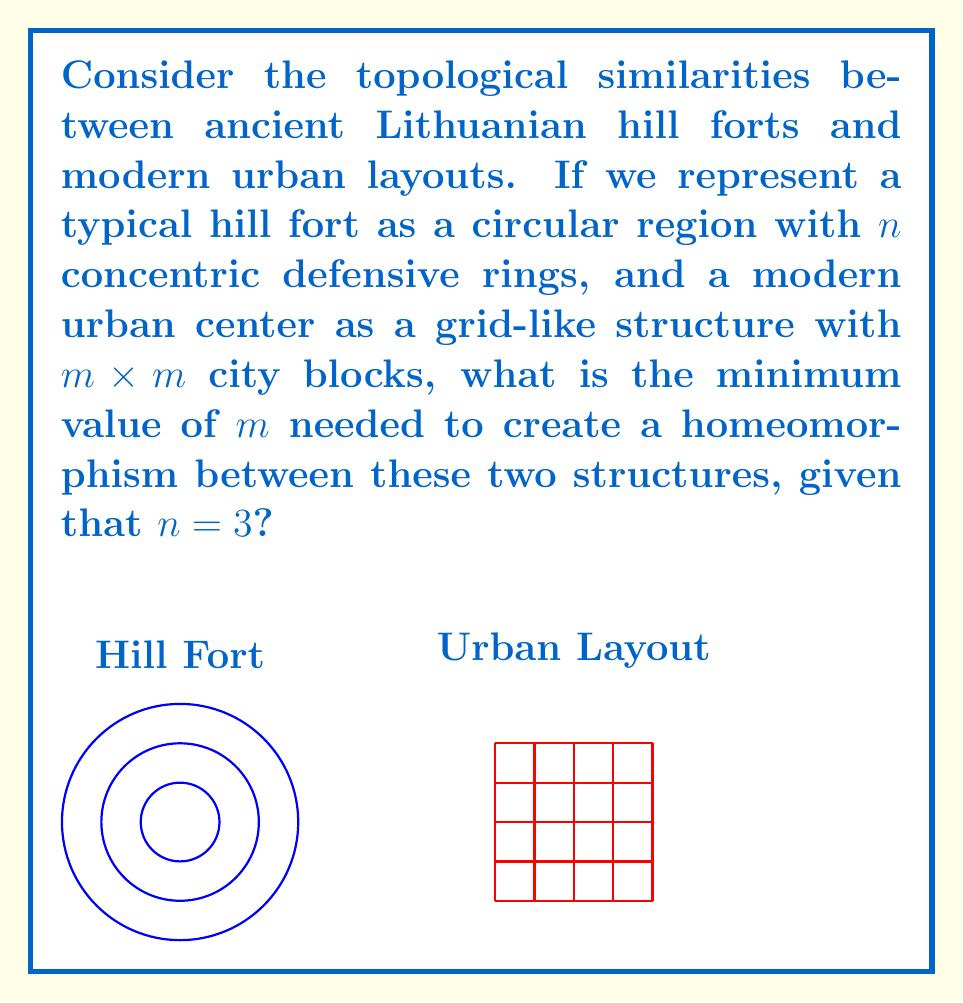Give your solution to this math problem. To analyze this problem, we need to consider the topological properties of both structures:

1) The hill fort with $n=3$ concentric rings can be viewed as four regions: the central area and three surrounding rings.

2) The urban layout with $m \times m$ city blocks forms $(m-1)^2$ intersections.

3) For a homeomorphism to exist, we need to preserve the essential topological features, particularly the number of distinct regions that can be continuously deformed into each other.

4) In the hill fort, we have 4 distinct regions (central area + 3 rings).

5) In the urban layout, we need to create at least 4 distinct regions that can be continuously deformed to match the hill fort structure.

6) The minimum number of intersections needed to create 4 distinct regions in a grid is 4, which occurs when we have a 3x3 grid of city blocks.

7) This 3x3 grid creates a central "block" surrounded by 8 outer blocks, which can be grouped into 3 "rings" around the center.

8) Therefore, the minimum value of $m$ that allows for a homeomorphism between the two structures is 3.

9) Mathematically, we can express this as:

   $$(m-1)^2 \geq n+1$$
   $$(m-1)^2 \geq 4$$
   $$m-1 \geq 2$$
   $$m \geq 3$$

Thus, the minimum integer value of $m$ that satisfies this inequality is 3.
Answer: $m = 3$ 